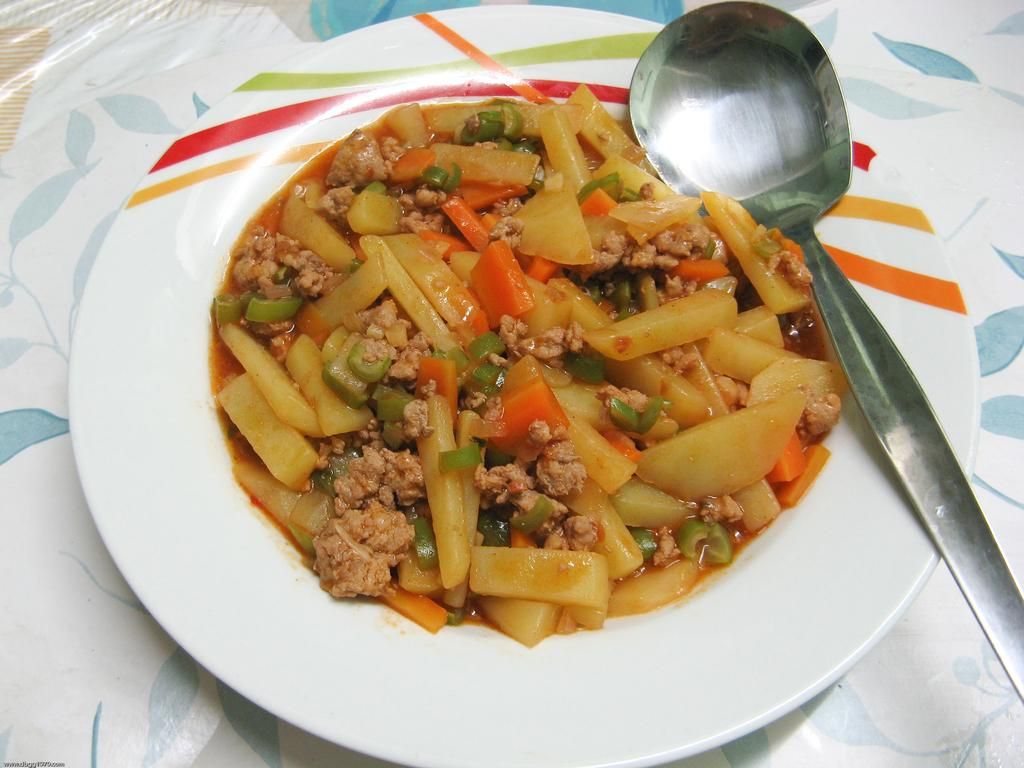What is on the plate that is visible in the image? There is a plate containing food in the image. What utensil is present in the image? There is a spoon in the image. What is covering the table in the image? The table is covered with a white tablecloth. Is there a table present in the image? Yes, the table is present in the image. What type of skate is being used by the person on the tablecloth in the image? There is no person skating on the tablecloth in the image, so it is not possible to determine what type of skate might be used. 